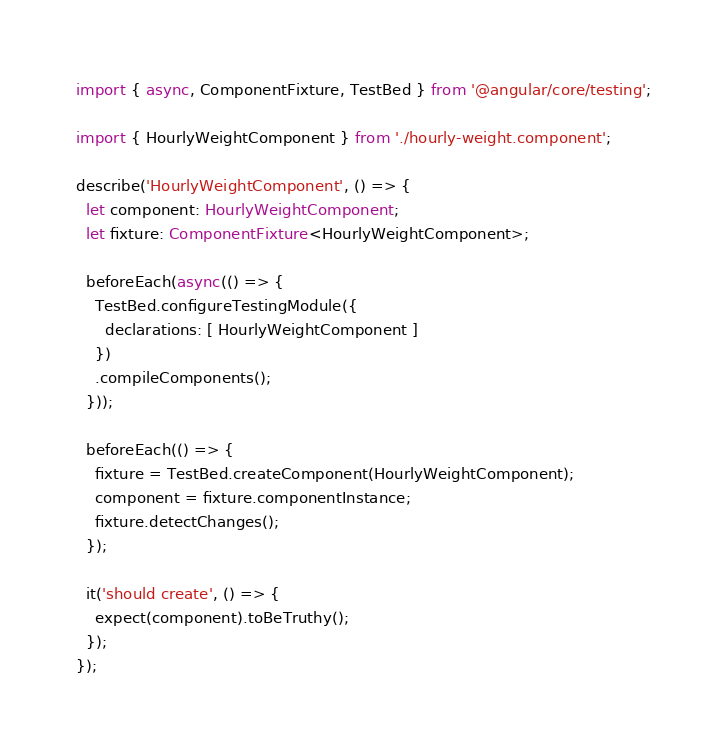<code> <loc_0><loc_0><loc_500><loc_500><_TypeScript_>import { async, ComponentFixture, TestBed } from '@angular/core/testing';

import { HourlyWeightComponent } from './hourly-weight.component';

describe('HourlyWeightComponent', () => {
  let component: HourlyWeightComponent;
  let fixture: ComponentFixture<HourlyWeightComponent>;

  beforeEach(async(() => {
    TestBed.configureTestingModule({
      declarations: [ HourlyWeightComponent ]
    })
    .compileComponents();
  }));

  beforeEach(() => {
    fixture = TestBed.createComponent(HourlyWeightComponent);
    component = fixture.componentInstance;
    fixture.detectChanges();
  });

  it('should create', () => {
    expect(component).toBeTruthy();
  });
});
</code> 